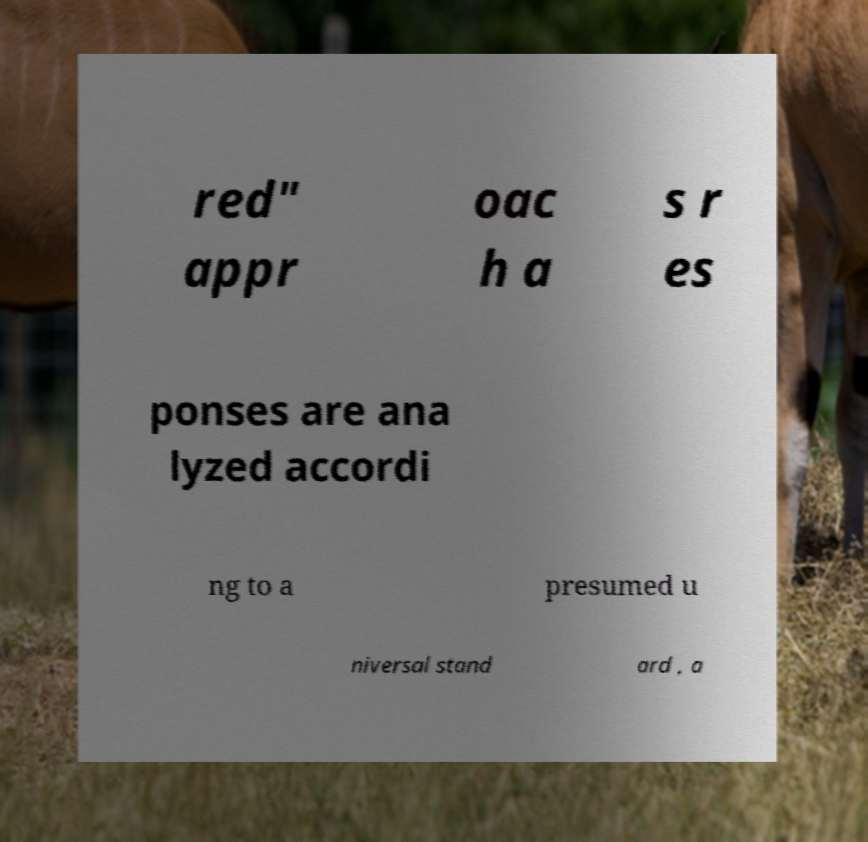Could you assist in decoding the text presented in this image and type it out clearly? red" appr oac h a s r es ponses are ana lyzed accordi ng to a presumed u niversal stand ard , a 